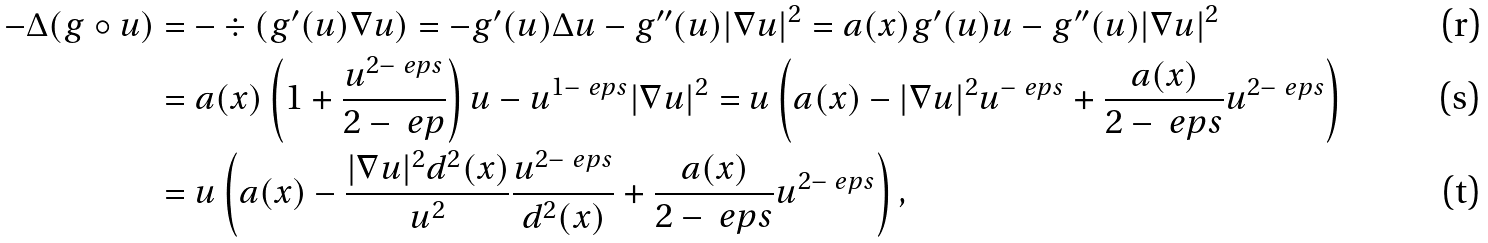Convert formula to latex. <formula><loc_0><loc_0><loc_500><loc_500>- \Delta ( g \circ u ) & = - \div ( g ^ { \prime } ( u ) \nabla u ) = - g ^ { \prime } ( u ) \Delta u - g ^ { \prime \prime } ( u ) | \nabla u | ^ { 2 } = a ( x ) g ^ { \prime } ( u ) u - g ^ { \prime \prime } ( u ) | \nabla u | ^ { 2 } \\ & = a ( x ) \left ( 1 + \frac { u ^ { 2 - \ e p s } } { 2 - \ e p } \right ) u - u ^ { 1 - \ e p s } | \nabla u | ^ { 2 } = u \left ( a ( x ) - | \nabla u | ^ { 2 } u ^ { - \ e p s } + \frac { a ( x ) } { 2 - \ e p s } u ^ { 2 - \ e p s } \right ) \\ & = u \left ( a ( x ) - \frac { | \nabla u | ^ { 2 } d ^ { 2 } ( x ) } { u ^ { 2 } } \frac { u ^ { 2 - \ e p s } } { d ^ { 2 } ( x ) } + \frac { a ( x ) } { 2 - \ e p s } u ^ { 2 - \ e p s } \right ) ,</formula> 